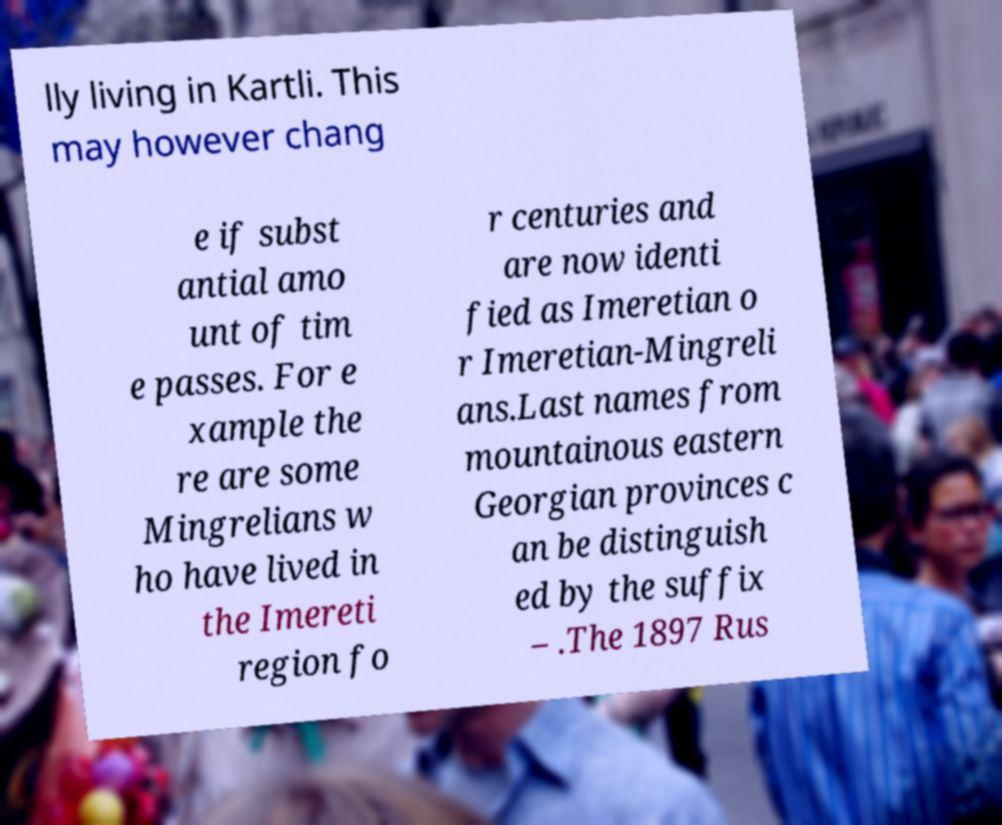Please identify and transcribe the text found in this image. lly living in Kartli. This may however chang e if subst antial amo unt of tim e passes. For e xample the re are some Mingrelians w ho have lived in the Imereti region fo r centuries and are now identi fied as Imeretian o r Imeretian-Mingreli ans.Last names from mountainous eastern Georgian provinces c an be distinguish ed by the suffix – .The 1897 Rus 